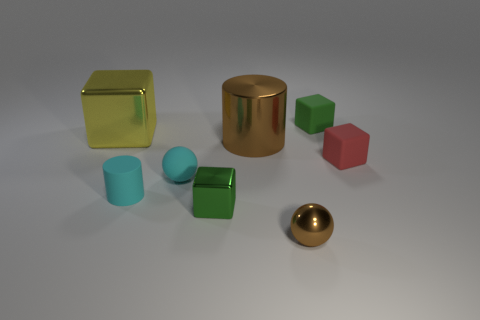Add 1 large yellow things. How many objects exist? 9 Subtract all cylinders. How many objects are left? 6 Subtract all big blue matte blocks. Subtract all brown cylinders. How many objects are left? 7 Add 2 small green shiny objects. How many small green shiny objects are left? 3 Add 4 gray metal cubes. How many gray metal cubes exist? 4 Subtract 0 gray blocks. How many objects are left? 8 